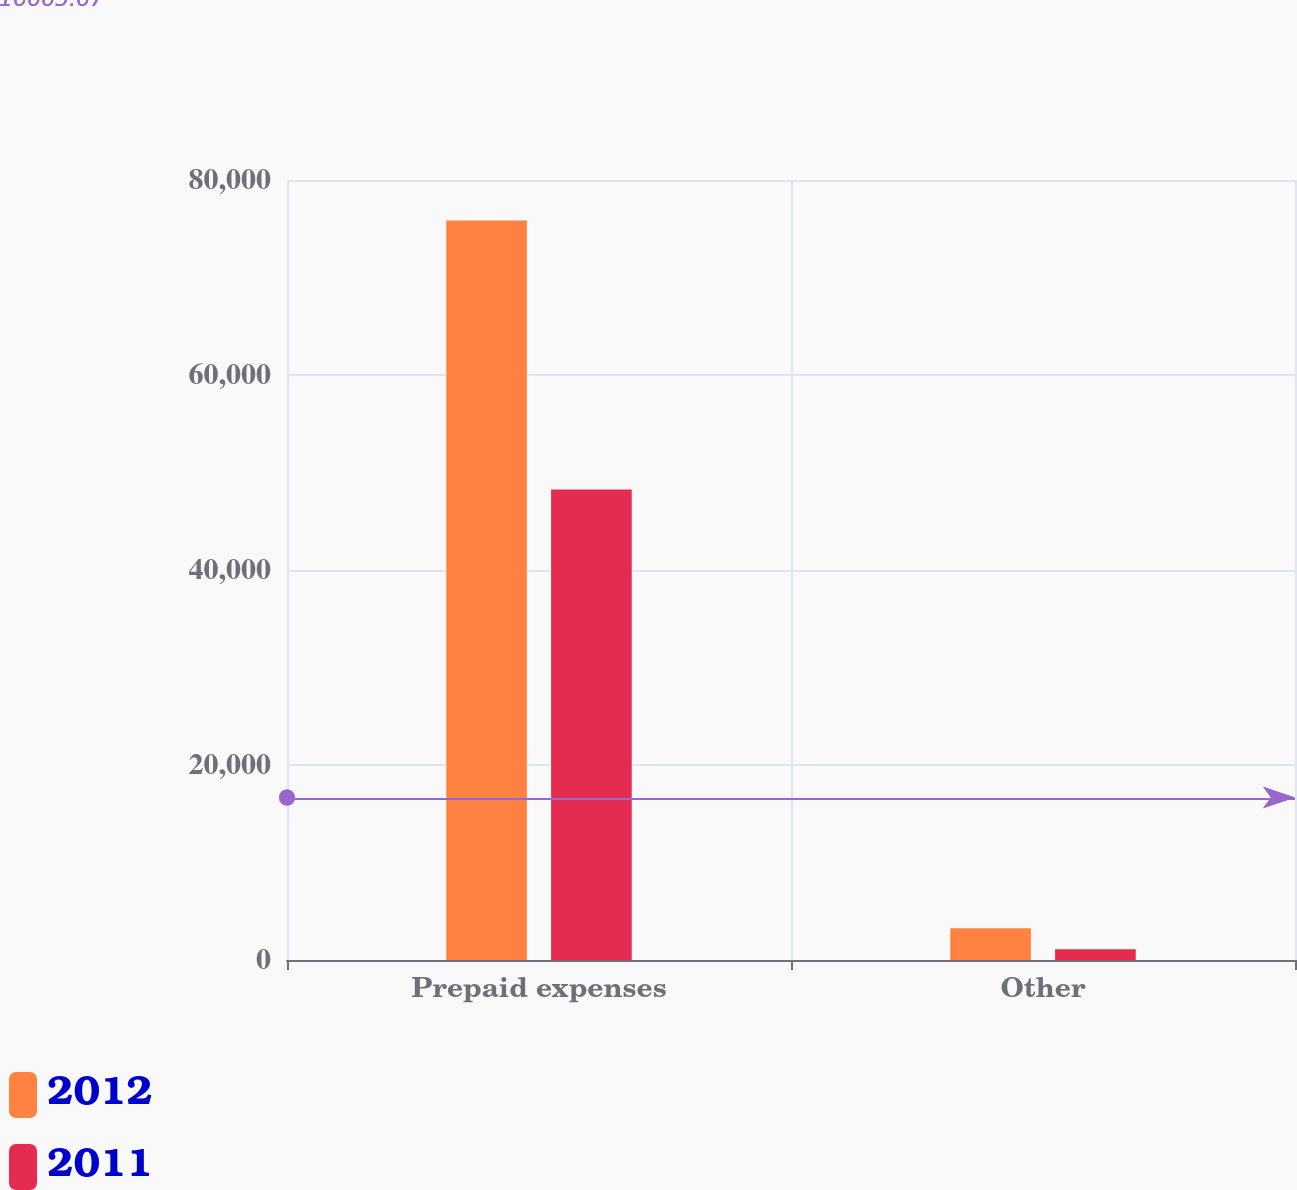Convert chart. <chart><loc_0><loc_0><loc_500><loc_500><stacked_bar_chart><ecel><fcel>Prepaid expenses<fcel>Other<nl><fcel>2012<fcel>75853<fcel>3250<nl><fcel>2011<fcel>48256<fcel>1093<nl></chart> 